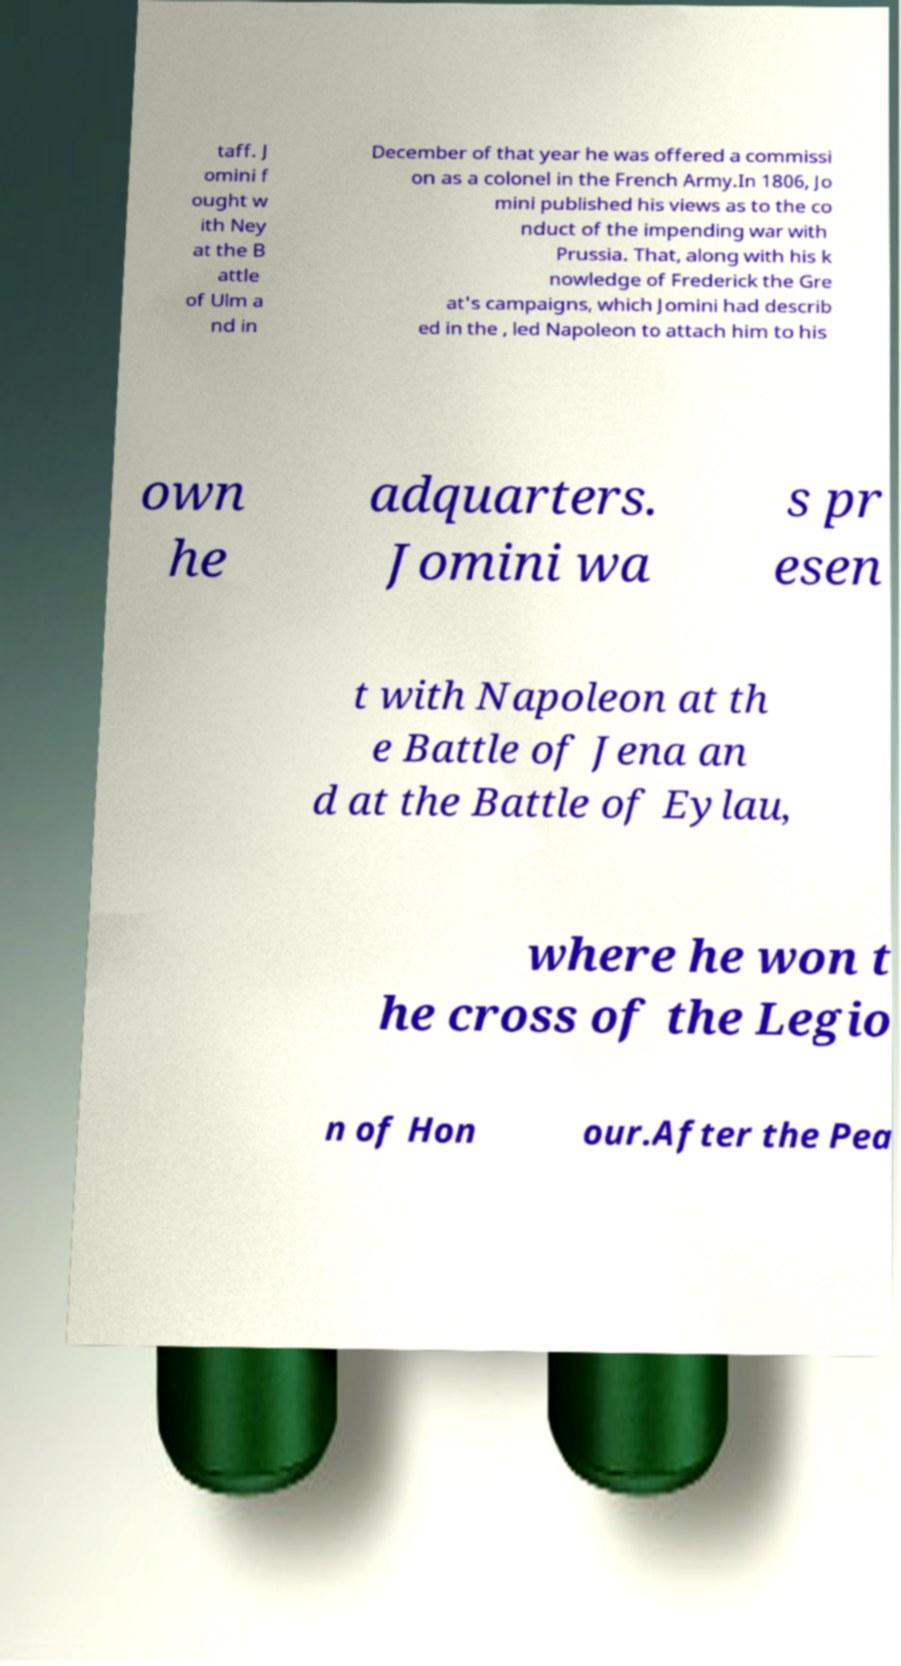For documentation purposes, I need the text within this image transcribed. Could you provide that? taff. J omini f ought w ith Ney at the B attle of Ulm a nd in December of that year he was offered a commissi on as a colonel in the French Army.In 1806, Jo mini published his views as to the co nduct of the impending war with Prussia. That, along with his k nowledge of Frederick the Gre at's campaigns, which Jomini had describ ed in the , led Napoleon to attach him to his own he adquarters. Jomini wa s pr esen t with Napoleon at th e Battle of Jena an d at the Battle of Eylau, where he won t he cross of the Legio n of Hon our.After the Pea 